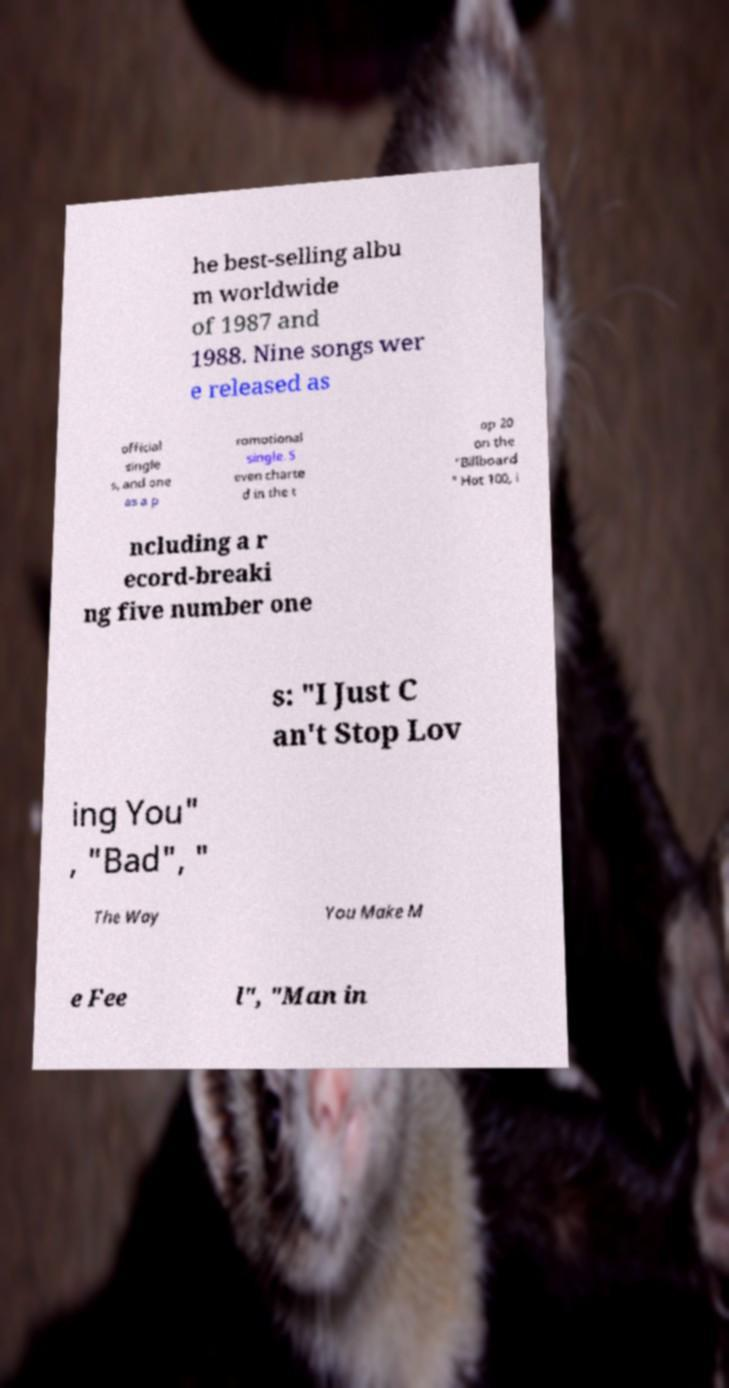There's text embedded in this image that I need extracted. Can you transcribe it verbatim? he best-selling albu m worldwide of 1987 and 1988. Nine songs wer e released as official single s, and one as a p romotional single. S even charte d in the t op 20 on the "Billboard " Hot 100, i ncluding a r ecord-breaki ng five number one s: "I Just C an't Stop Lov ing You" , "Bad", " The Way You Make M e Fee l", "Man in 